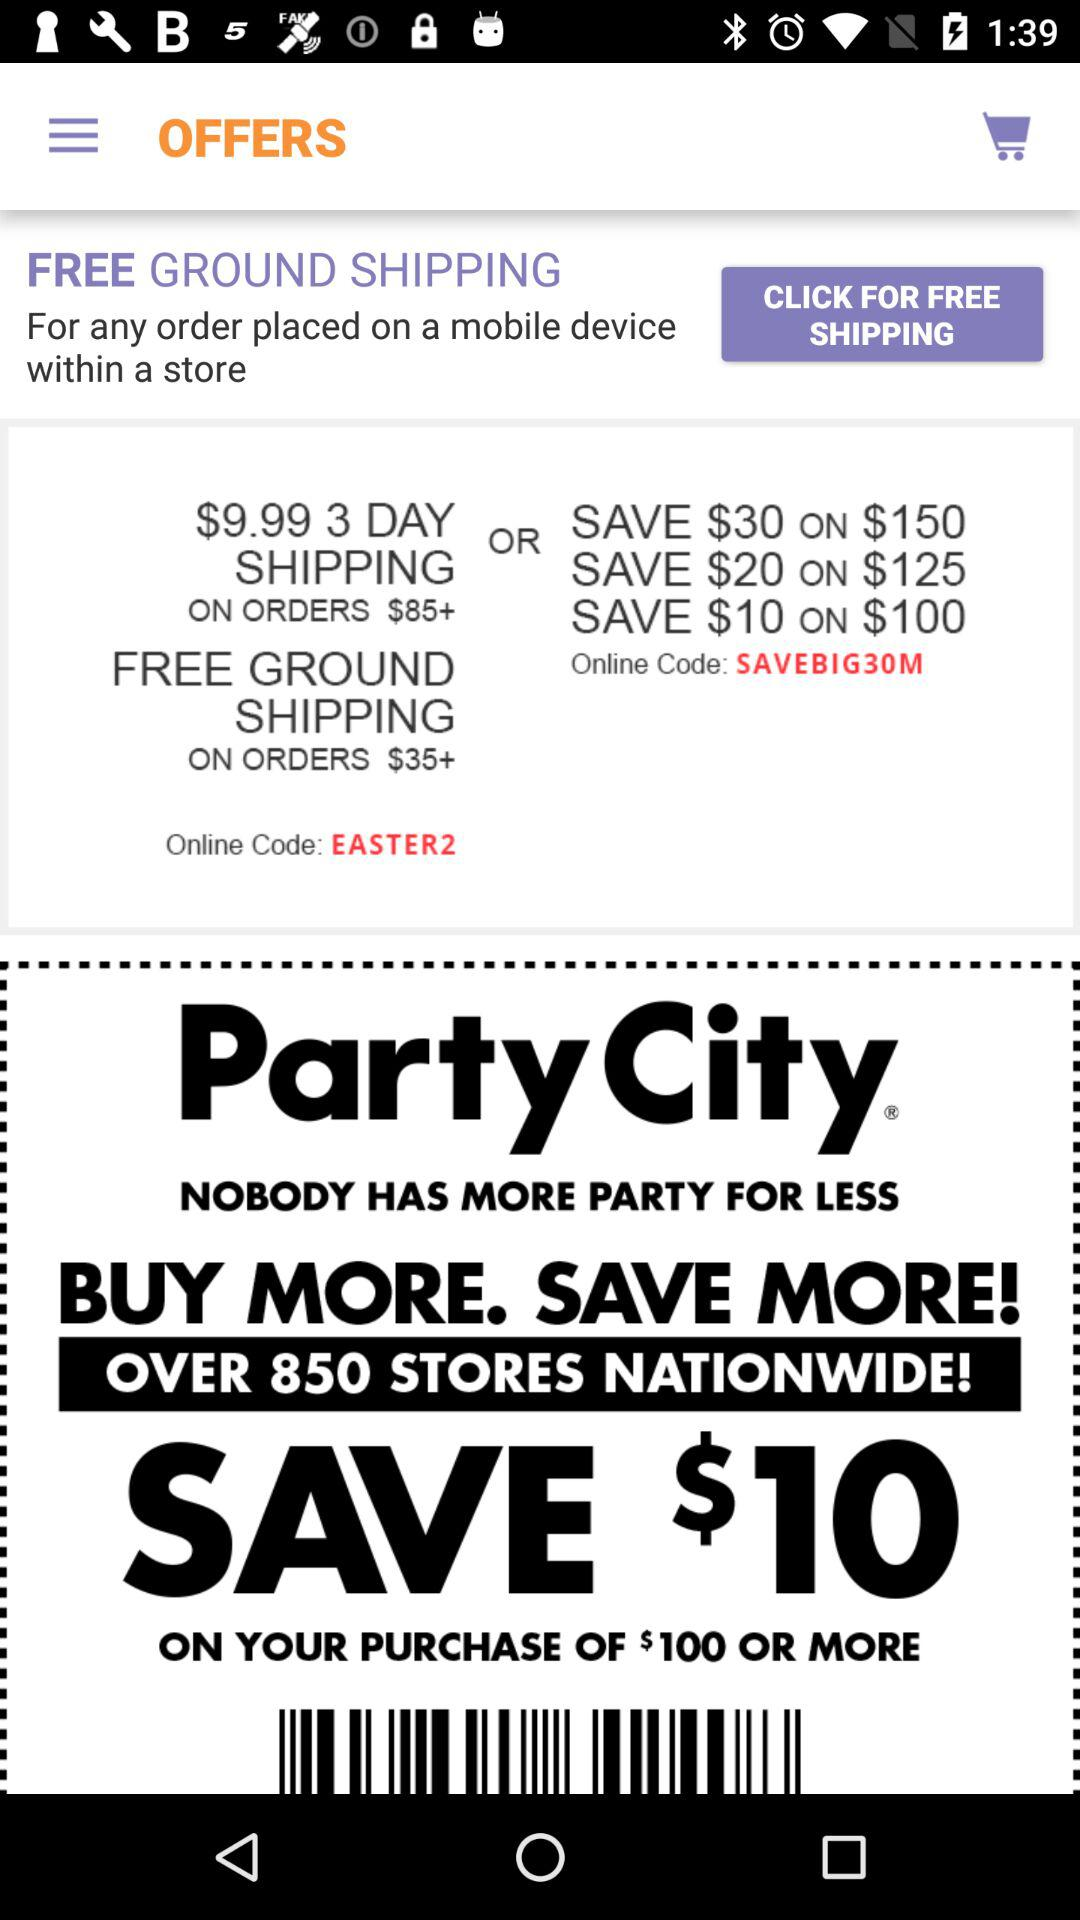How much of a discount is available on the purchase of $100? On the $100 purchase, there is a discount of $10 available. 